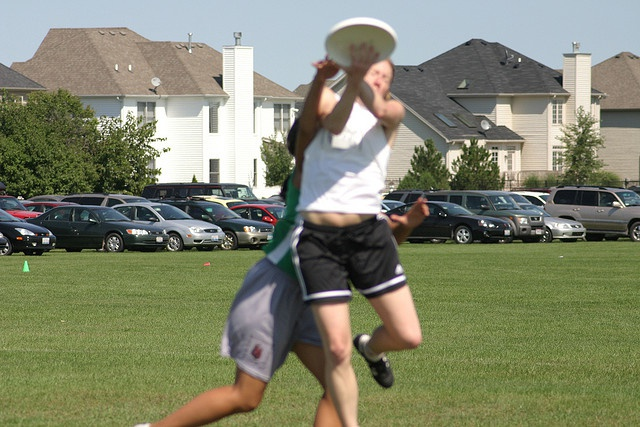Describe the objects in this image and their specific colors. I can see people in lightgray, black, white, gray, and darkgray tones, people in lightgray, black, gray, darkgray, and salmon tones, car in lightgray, black, gray, purple, and darkgray tones, car in lightgray, black, and gray tones, and car in lightgray, black, gray, and darkgray tones in this image. 